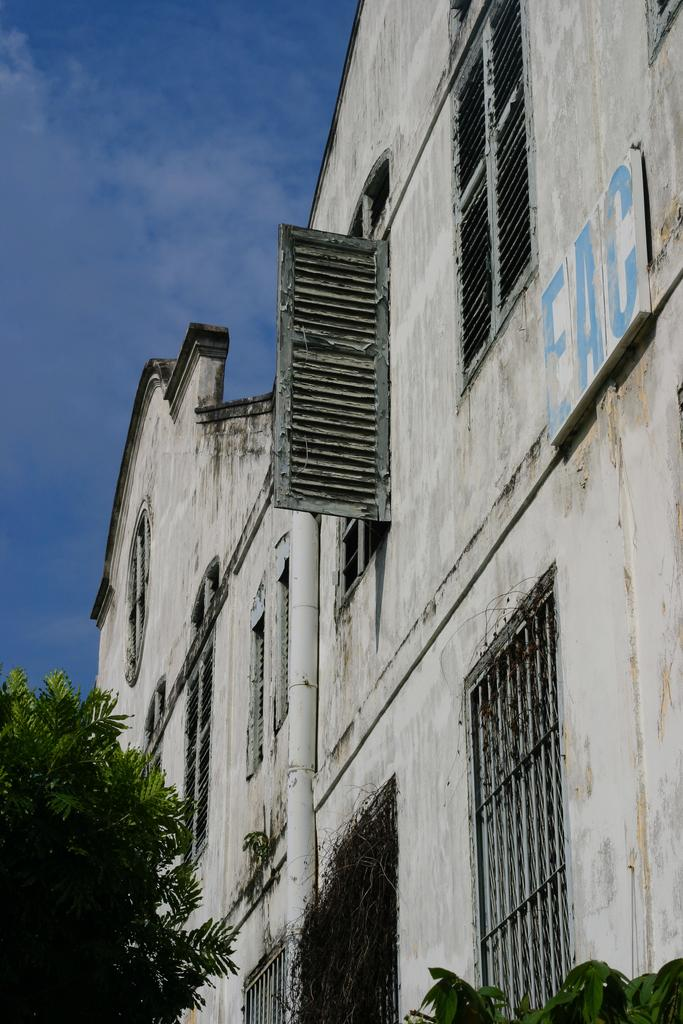What type of structures can be seen in the image? There are buildings in the image. What feature is visible on the buildings? There are windows visible in the image. What is written or displayed on a board in the image? There is a board with text in the image. What type of natural vegetation is present in the image? There are trees in the image. What part of the natural environment is visible in the image? The sky is visible in the image. Where is the doctor's office located in the image? There is no doctor's office present in the image. What type of holiday is being celebrated in the image? There is no indication of a holiday being celebrated in the image. 